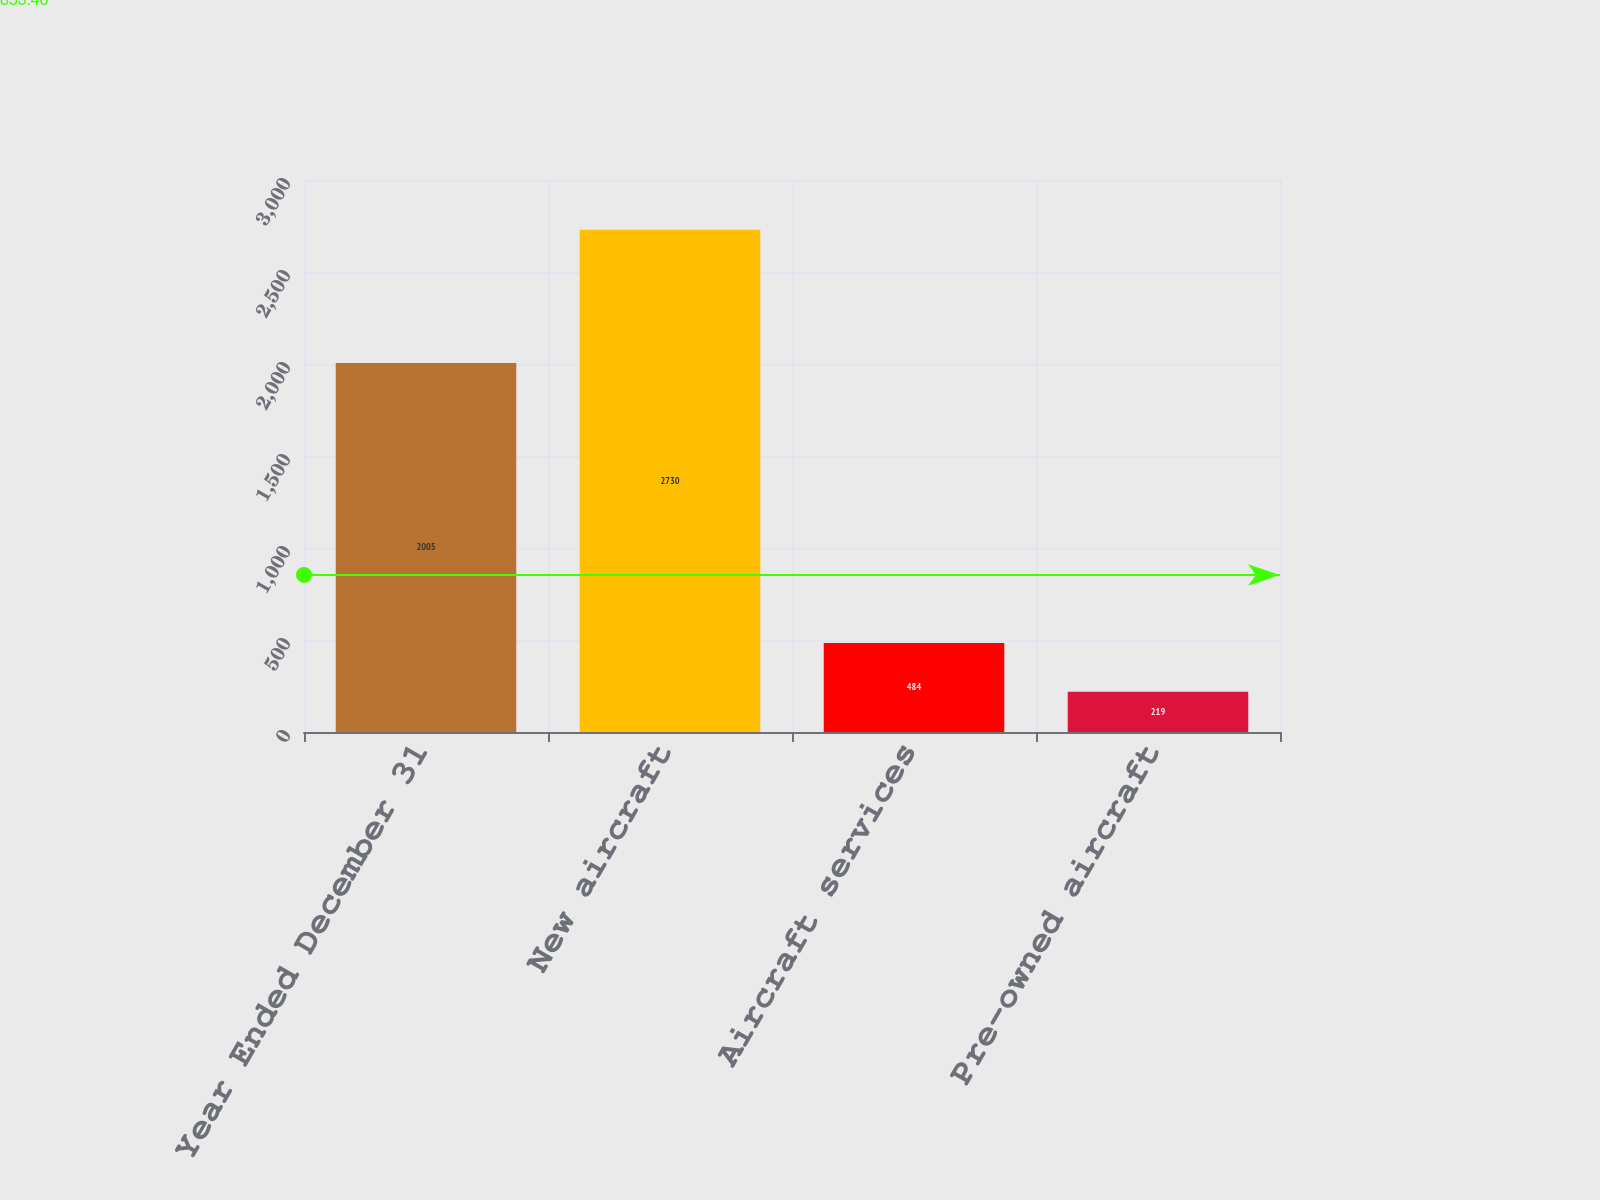Convert chart. <chart><loc_0><loc_0><loc_500><loc_500><bar_chart><fcel>Year Ended December 31<fcel>New aircraft<fcel>Aircraft services<fcel>Pre-owned aircraft<nl><fcel>2005<fcel>2730<fcel>484<fcel>219<nl></chart> 